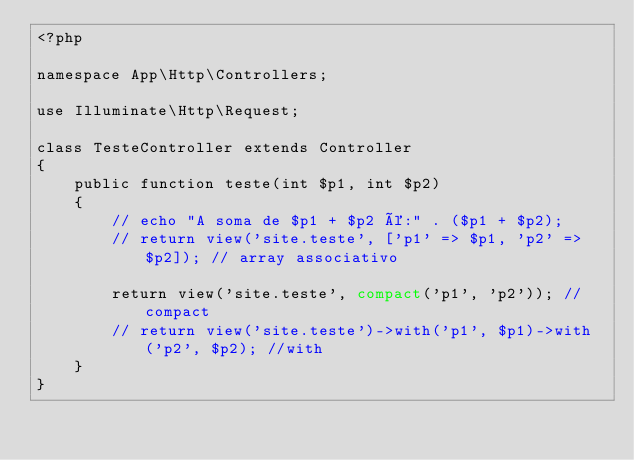<code> <loc_0><loc_0><loc_500><loc_500><_PHP_><?php

namespace App\Http\Controllers;

use Illuminate\Http\Request;

class TesteController extends Controller
{
    public function teste(int $p1, int $p2)
    {
        // echo "A soma de $p1 + $p2 é:" . ($p1 + $p2);
        // return view('site.teste', ['p1' => $p1, 'p2' => $p2]); // array associativo

        return view('site.teste', compact('p1', 'p2')); //compact
        // return view('site.teste')->with('p1', $p1)->with('p2', $p2); //with
    }
}
</code> 